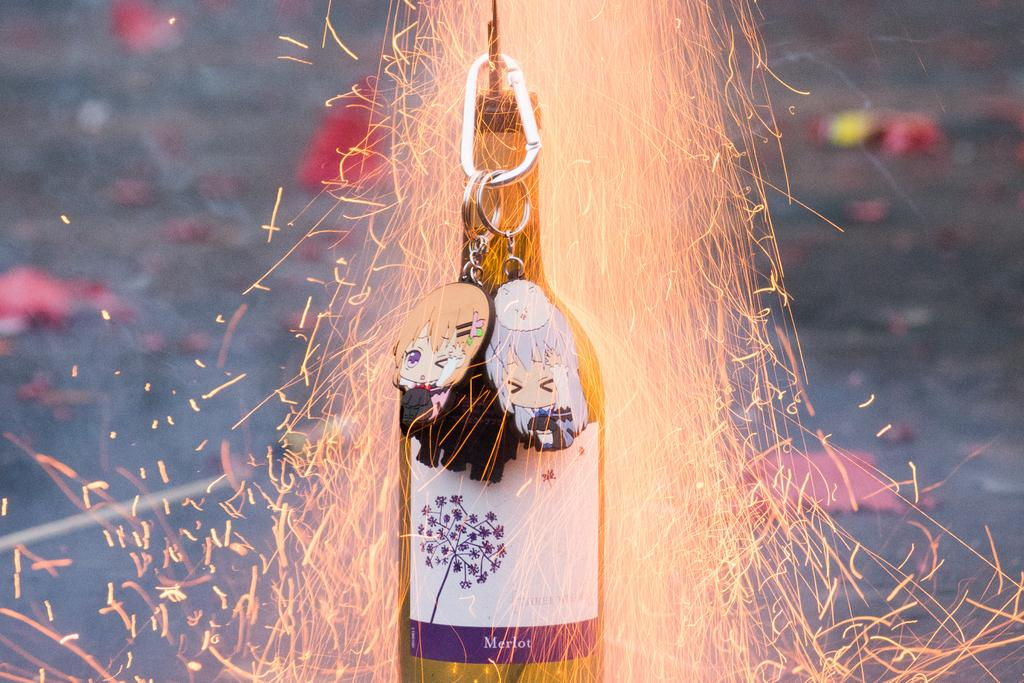What is present in the image that can hold a liquid? There is a bottle in the image that can hold a liquid. What is depicted as being on fire in the image? There is a cracker with fire in the image. What type of items are hanging from the bottle in the image? Keychains are hanging from the bottle in the image. How many jellyfish can be seen swimming in the image? There are no jellyfish present in the image. What type of bee is buzzing around the cracker with fire in the image? There are no bees present in the image. 